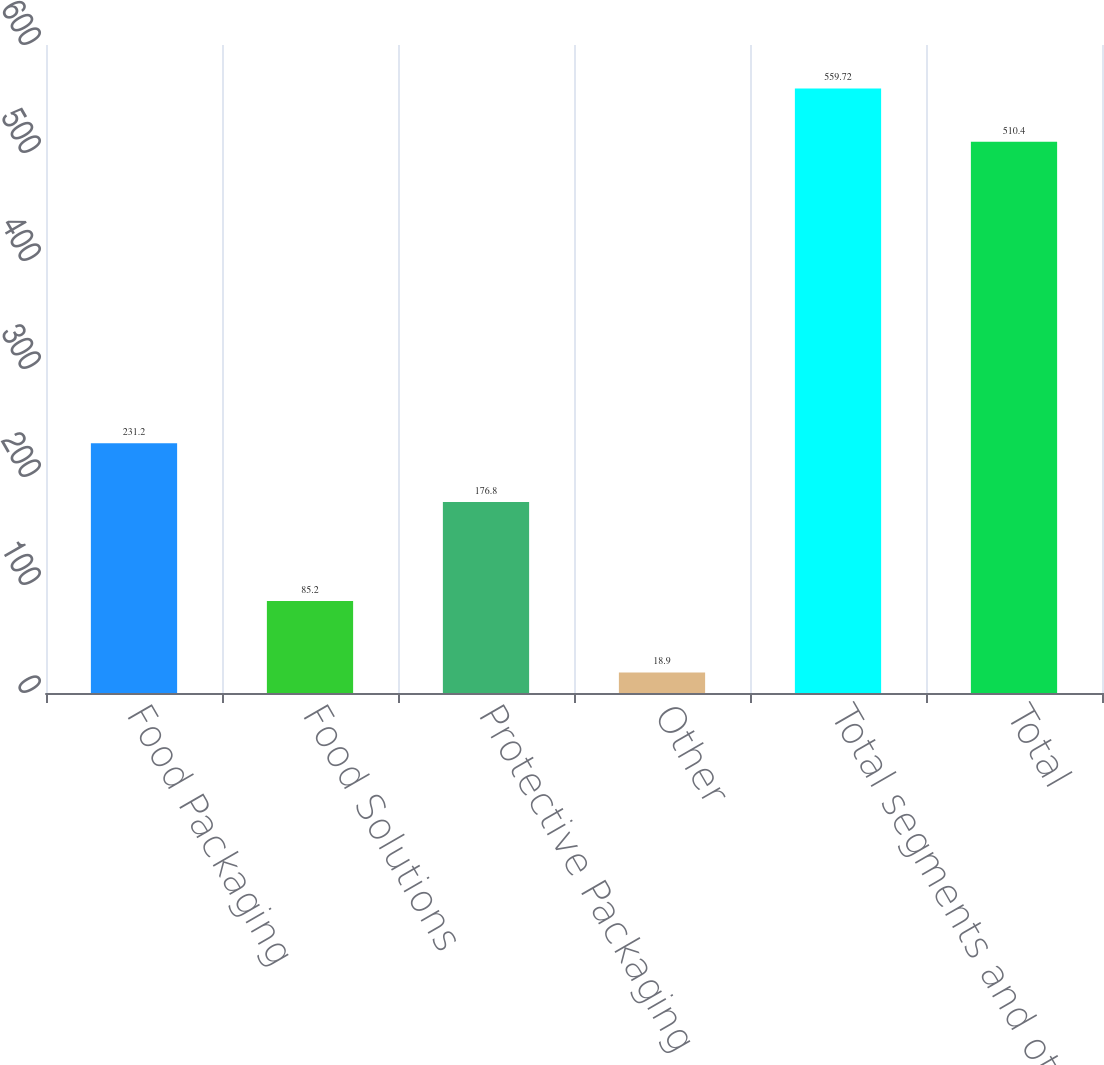Convert chart. <chart><loc_0><loc_0><loc_500><loc_500><bar_chart><fcel>Food Packaging<fcel>Food Solutions<fcel>Protective Packaging<fcel>Other<fcel>Total segments and other<fcel>Total<nl><fcel>231.2<fcel>85.2<fcel>176.8<fcel>18.9<fcel>559.72<fcel>510.4<nl></chart> 